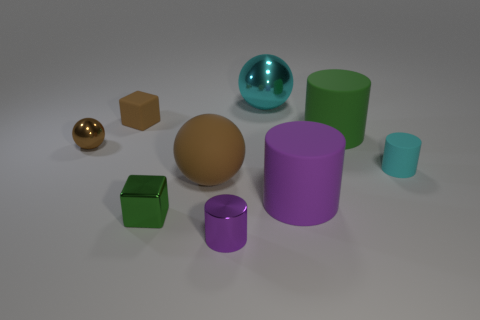Is there any other thing that has the same size as the brown cube?
Offer a very short reply. Yes. How many big balls are to the right of the small green block?
Offer a terse response. 2. There is a metallic ball that is on the right side of the shiny cylinder; is its size the same as the green block?
Offer a very short reply. No. The other metallic thing that is the same shape as the cyan shiny thing is what color?
Provide a succinct answer. Brown. Are there any other things that are the same shape as the big green object?
Your answer should be very brief. Yes. There is a purple rubber thing that is right of the big cyan object; what is its shape?
Provide a short and direct response. Cylinder. What number of big purple objects have the same shape as the tiny brown metallic object?
Offer a terse response. 0. There is a small rubber object on the right side of the green rubber thing; is it the same color as the big matte cylinder that is to the right of the large purple rubber object?
Keep it short and to the point. No. How many objects are metal balls or big green rubber objects?
Make the answer very short. 3. How many other big things have the same material as the big brown thing?
Offer a terse response. 2. 